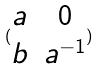Convert formula to latex. <formula><loc_0><loc_0><loc_500><loc_500>( \begin{matrix} a & 0 \\ b & a ^ { - 1 } \end{matrix} )</formula> 